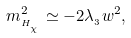Convert formula to latex. <formula><loc_0><loc_0><loc_500><loc_500>m _ { _ { H _ { _ { _ { \chi } } } } } ^ { 2 } \simeq - 2 \lambda _ { _ { 3 } } w ^ { 2 } ,</formula> 